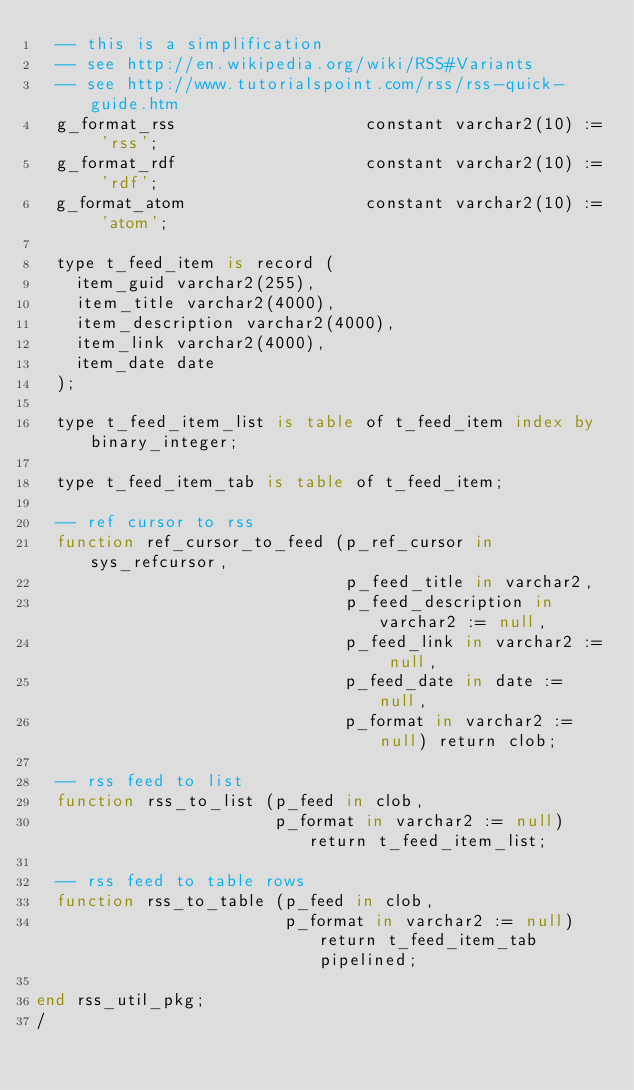Convert code to text. <code><loc_0><loc_0><loc_500><loc_500><_SQL_>  -- this is a simplification
  -- see http://en.wikipedia.org/wiki/RSS#Variants
  -- see http://www.tutorialspoint.com/rss/rss-quick-guide.htm
  g_format_rss                   constant varchar2(10) := 'rss';
  g_format_rdf                   constant varchar2(10) := 'rdf';
  g_format_atom                  constant varchar2(10) := 'atom';

  type t_feed_item is record (
    item_guid varchar2(255),
    item_title varchar2(4000),
    item_description varchar2(4000),
    item_link varchar2(4000),
    item_date date
  );

  type t_feed_item_list is table of t_feed_item index by binary_integer;
  
  type t_feed_item_tab is table of t_feed_item;

  -- ref cursor to rss
  function ref_cursor_to_feed (p_ref_cursor in sys_refcursor,
                               p_feed_title in varchar2,
                               p_feed_description in varchar2 := null,
                               p_feed_link in varchar2 := null,
                               p_feed_date in date := null,
                               p_format in varchar2 := null) return clob;
                               
  -- rss feed to list
  function rss_to_list (p_feed in clob,
                        p_format in varchar2 := null) return t_feed_item_list;

  -- rss feed to table rows
  function rss_to_table (p_feed in clob,
                         p_format in varchar2 := null) return t_feed_item_tab pipelined;

end rss_util_pkg;
/

</code> 